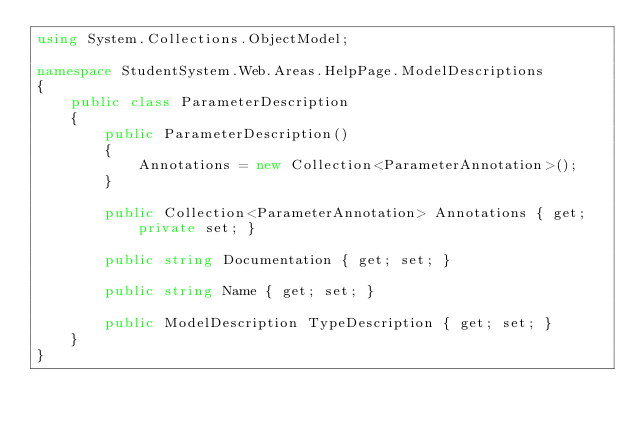Convert code to text. <code><loc_0><loc_0><loc_500><loc_500><_C#_>using System.Collections.ObjectModel;

namespace StudentSystem.Web.Areas.HelpPage.ModelDescriptions
{
    public class ParameterDescription
    {
        public ParameterDescription()
        {
            Annotations = new Collection<ParameterAnnotation>();
        }

        public Collection<ParameterAnnotation> Annotations { get; private set; }

        public string Documentation { get; set; }

        public string Name { get; set; }

        public ModelDescription TypeDescription { get; set; }
    }
}</code> 